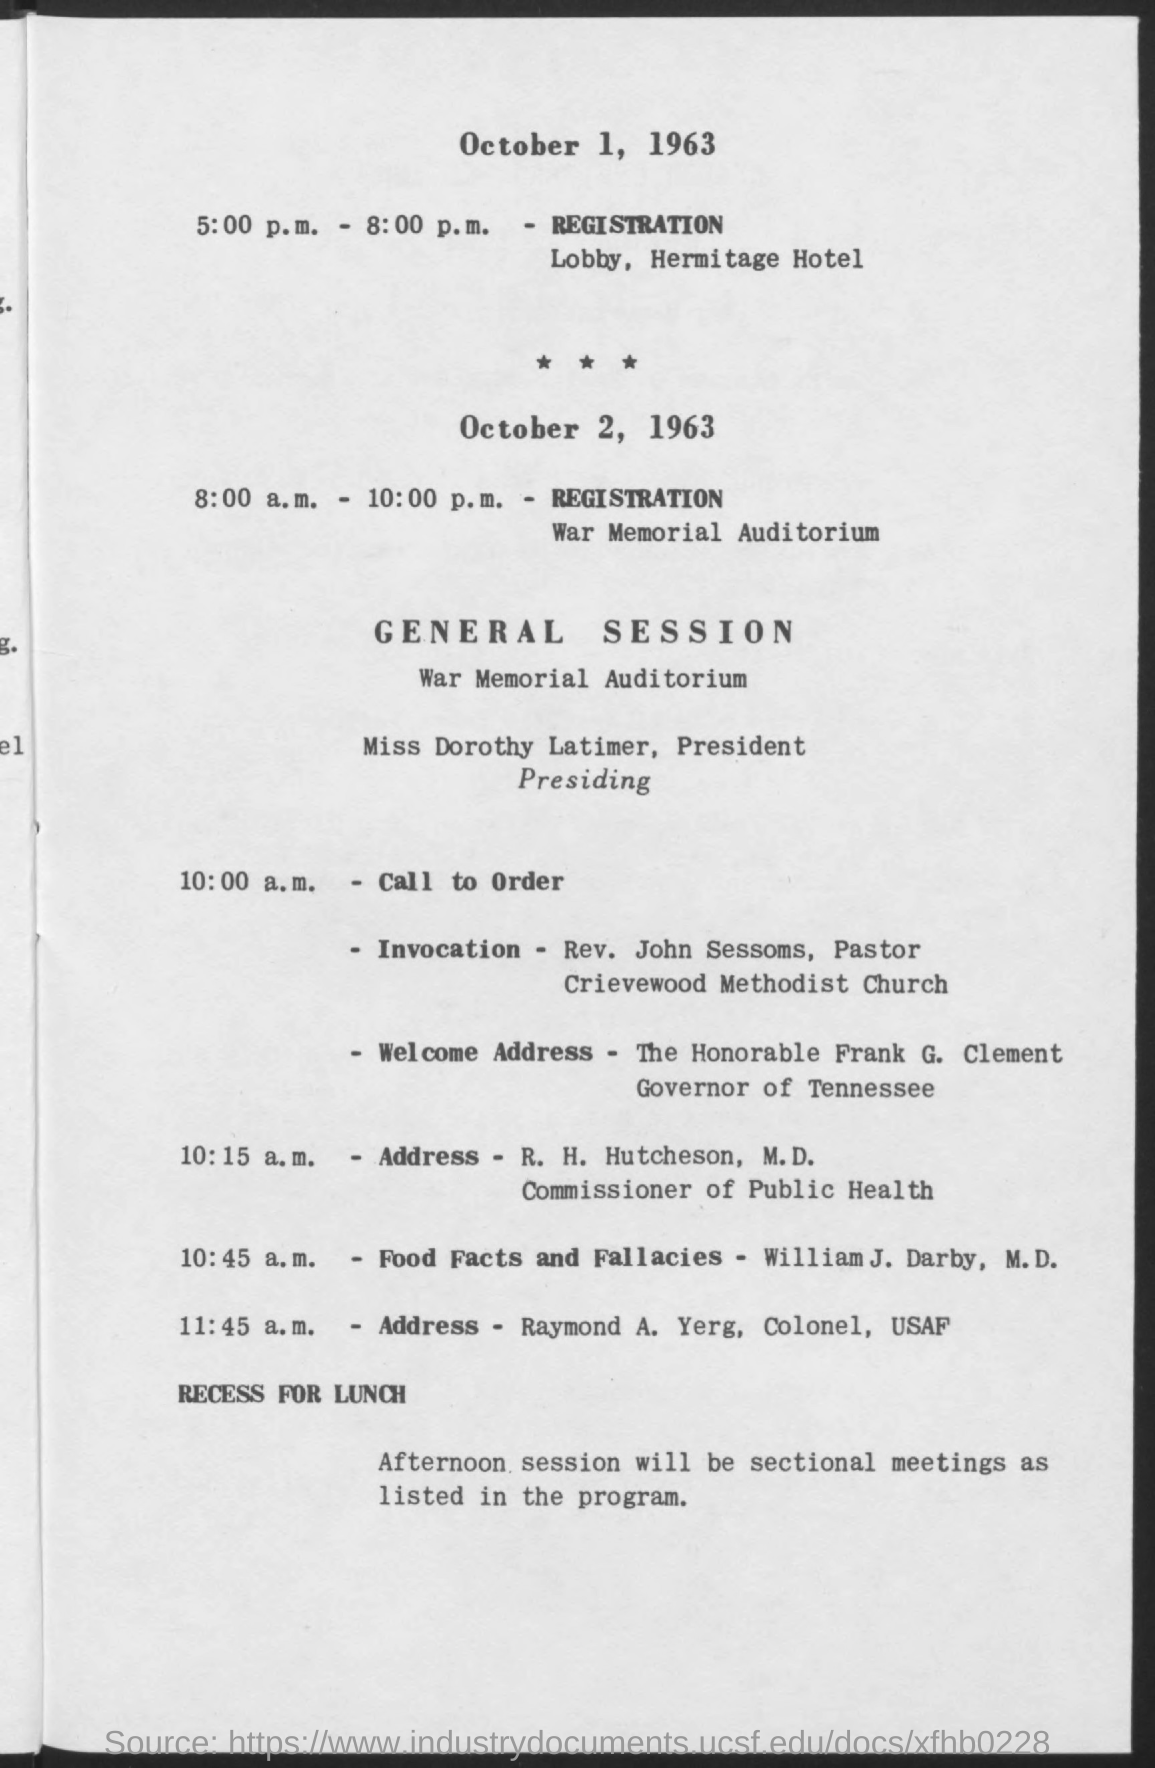When is the registration on October 1, 1963?
Provide a short and direct response. 5:00 p.m. - 8:00 p.m. Where is the registration on October 1, 1963?
Make the answer very short. Lobby, Hermitage Hotel. Where is the registration on October 2, 1963?
Give a very brief answer. War Memorial Auditorium. When is the registration on October 2, 1963?
Provide a short and direct response. 8:00 a.m. - 10:00 p.m. Who is presiding the general session?
Your answer should be compact. Miss Dorothy Latimer. When is the Invocation?
Keep it short and to the point. 10:00 a.m. Who is the Governor of Tennessee?
Ensure brevity in your answer.  The Honorable Frank G. Clement. When is the address by Raymond A. Yerg, Colonel, USAF?
Give a very brief answer. 11:45 a.m. 